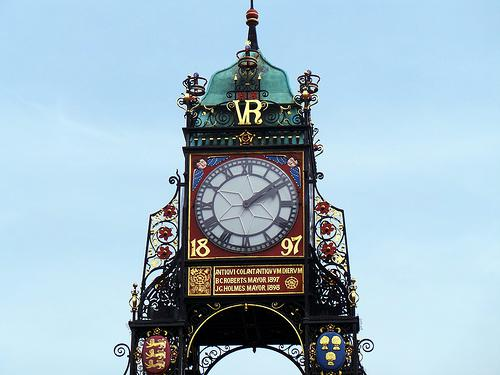Question: where is the clock?
Choices:
A. On tower.
B. On the wall.
C. In the window.
D. On the ground.
Answer with the letter. Answer: A Question: what color are the numbers?
Choices:
A. Black.
B. Purple.
C. Gold.
D. White.
Answer with the letter. Answer: C Question: where are the numbers located?
Choices:
A. On clock.
B. On the wall.
C. In the street.
D. On the sign.
Answer with the letter. Answer: A 